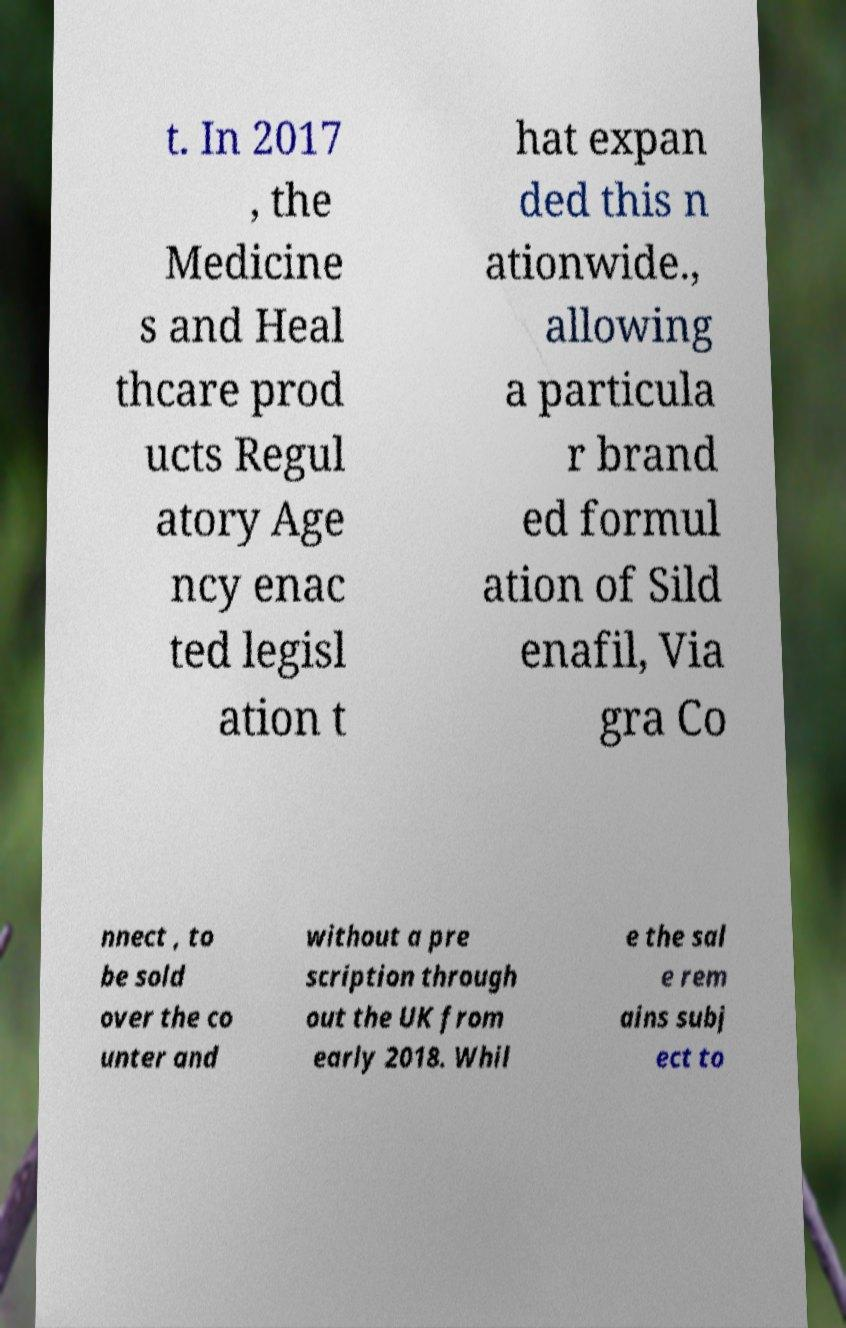Can you read and provide the text displayed in the image?This photo seems to have some interesting text. Can you extract and type it out for me? t. In 2017 , the Medicine s and Heal thcare prod ucts Regul atory Age ncy enac ted legisl ation t hat expan ded this n ationwide., allowing a particula r brand ed formul ation of Sild enafil, Via gra Co nnect , to be sold over the co unter and without a pre scription through out the UK from early 2018. Whil e the sal e rem ains subj ect to 